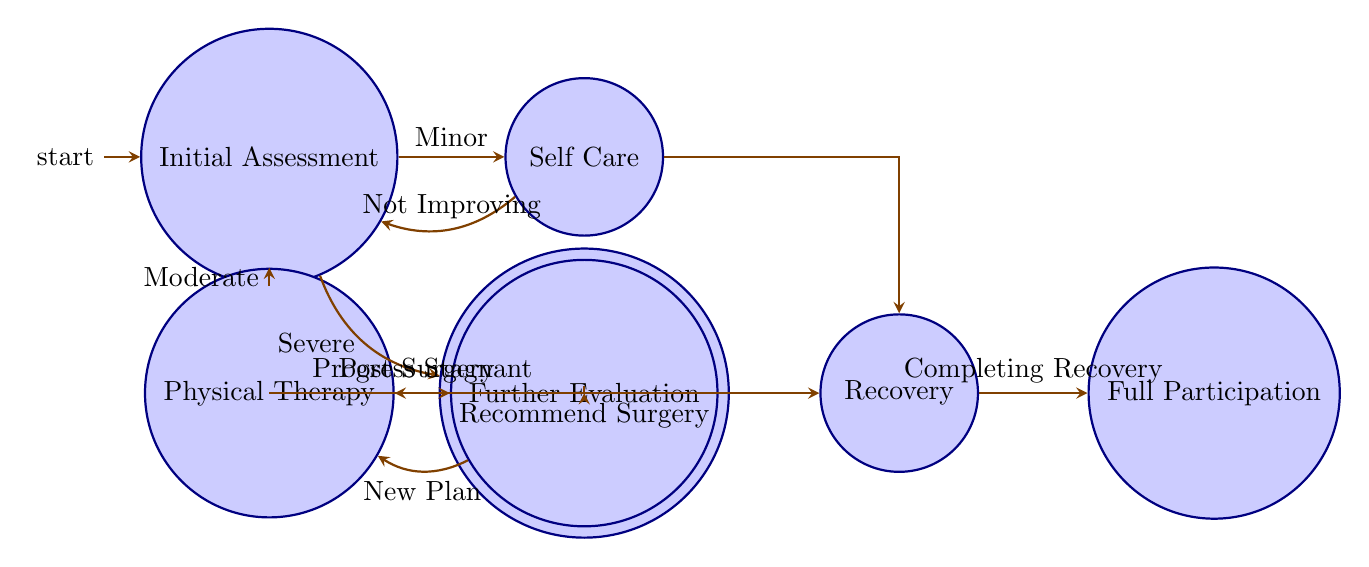What is the first state in the diagram? The diagram starts with the state labeled "Initial Assessment," which evaluates the injury severity.
Answer: Initial Assessment How many states are there in total? Counting the distinct states in the diagram, we find there are seven states: Initial Assessment, Self Care, Physical Therapy, Surgical Intervention, Further Evaluation, Recovery, and Full Participation.
Answer: Seven What action follows a "Severe" injury? In the case of a "Severe" injury, the action taken is to "Proceed to Surgical Intervention."
Answer: Proceed to Surgical Intervention What is the transition condition from Self Care to Recovery? The condition for transitioning from Self Care to Recovery is "Improving," indicating that the minor injury is healing well.
Answer: Improving What state leads to Further Evaluation? The state that leads to Further Evaluation is "Physical Therapy," specifically when progress is stagnant.
Answer: Physical Therapy After a surgical intervention, what is the next step? After undergoing a surgical intervention, the next step is to "Proceed to Physical Therapy" during the recovery phase.
Answer: Proceed to Physical Therapy What is the final state in the diagram? The final state in the diagram is labeled "Full Participation," where the athlete is cleared for unrestricted activities.
Answer: Full Participation If progress is stagnant in Physical Therapy, where do you go next? If progress is stagnant in Physical Therapy, the next step is to "Proceed to Further Evaluation." This allows for additional assessment and adjustments to the rehabilitation plan.
Answer: Proceed to Further Evaluation What happens if recovery is completed? Upon completing recovery, the action taken is to "Proceed to Full Participation," allowing the athlete a return to all sporting activities.
Answer: Proceed to Full Participation 